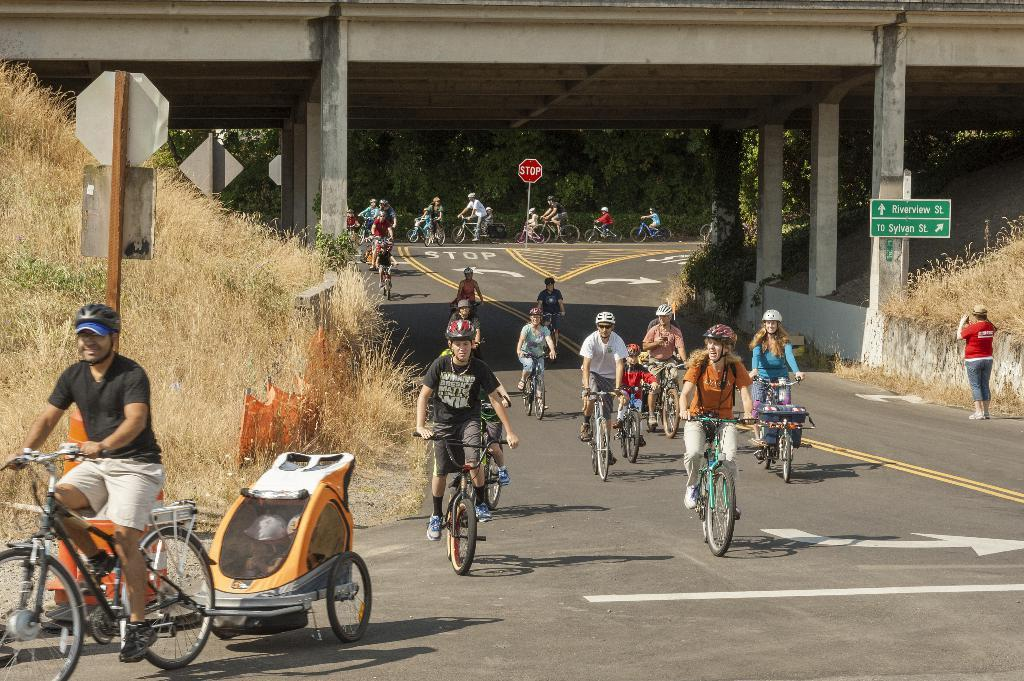Who is present in the image? There are people in the image. What are the people doing in the image? The people are riding bicycles. What structure can be seen in the image? There is a bridge in the image. What type of card is being used to repair the bridge in the image? There is no card or repair work being done on the bridge in the image. 